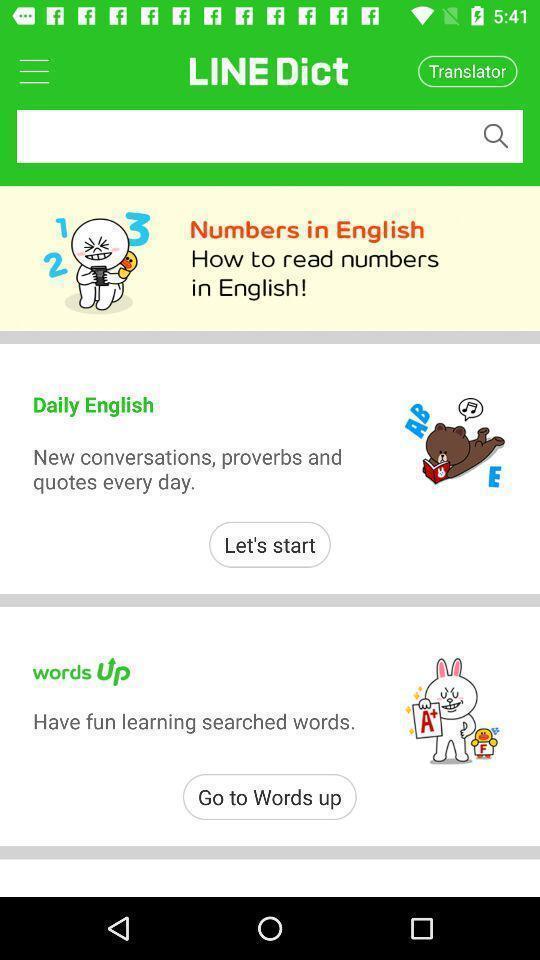Summarize the information in this screenshot. Page showing different options in a language learning app. 